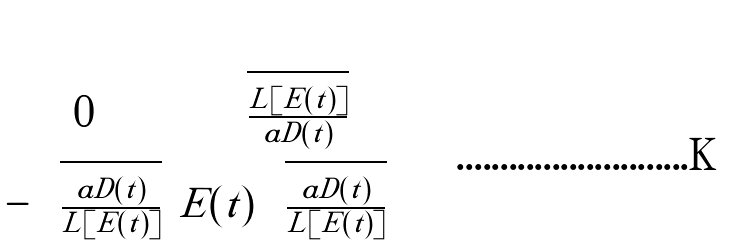Convert formula to latex. <formula><loc_0><loc_0><loc_500><loc_500>\begin{pmatrix} 0 & \sqrt { \frac { L [ E ( t ) ] } { a D ( t ) } } \\ - \sqrt { \frac { a D ( t ) } { L [ E ( t ) ] } } & E ( t ) \sqrt { \frac { a D ( t ) } { L [ E ( t ) ] } } \end{pmatrix}</formula> 